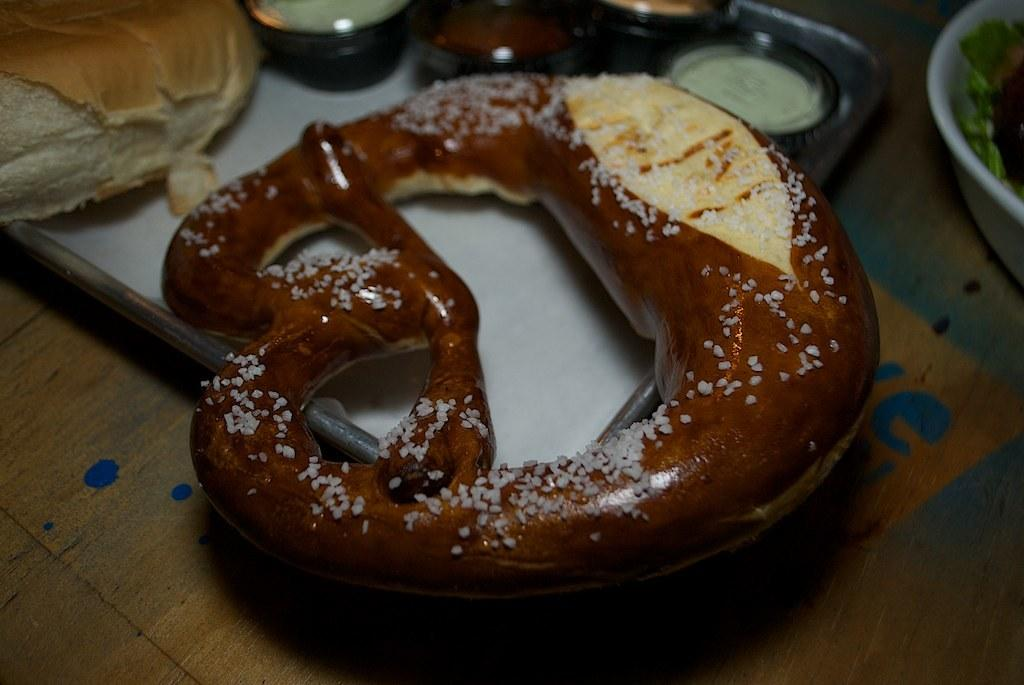What is on the plate in the foreground of the image? There is a lye roll in the plate in the foreground of the image. What can be found on the right side of the image? There is a bowl on the right side of the image. What is on the left side of the image? There is a bread in a plate on the left side of the image. Can you describe the arrangement of the bowls in the image? There are a few bowls on top of the other elements in the image. What type of stamp is visible on the bread? There is no stamp present on the bread or any other element in the image. 